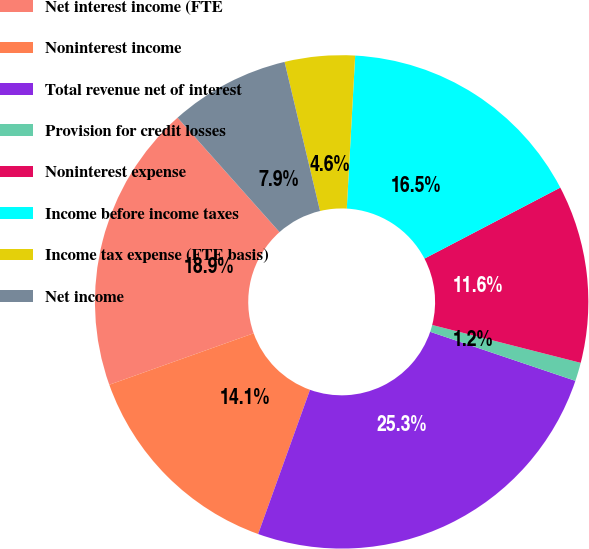Convert chart. <chart><loc_0><loc_0><loc_500><loc_500><pie_chart><fcel>Net interest income (FTE<fcel>Noninterest income<fcel>Total revenue net of interest<fcel>Provision for credit losses<fcel>Noninterest expense<fcel>Income before income taxes<fcel>Income tax expense (FTE basis)<fcel>Net income<nl><fcel>18.87%<fcel>14.05%<fcel>25.31%<fcel>1.21%<fcel>11.64%<fcel>16.46%<fcel>4.59%<fcel>7.86%<nl></chart> 